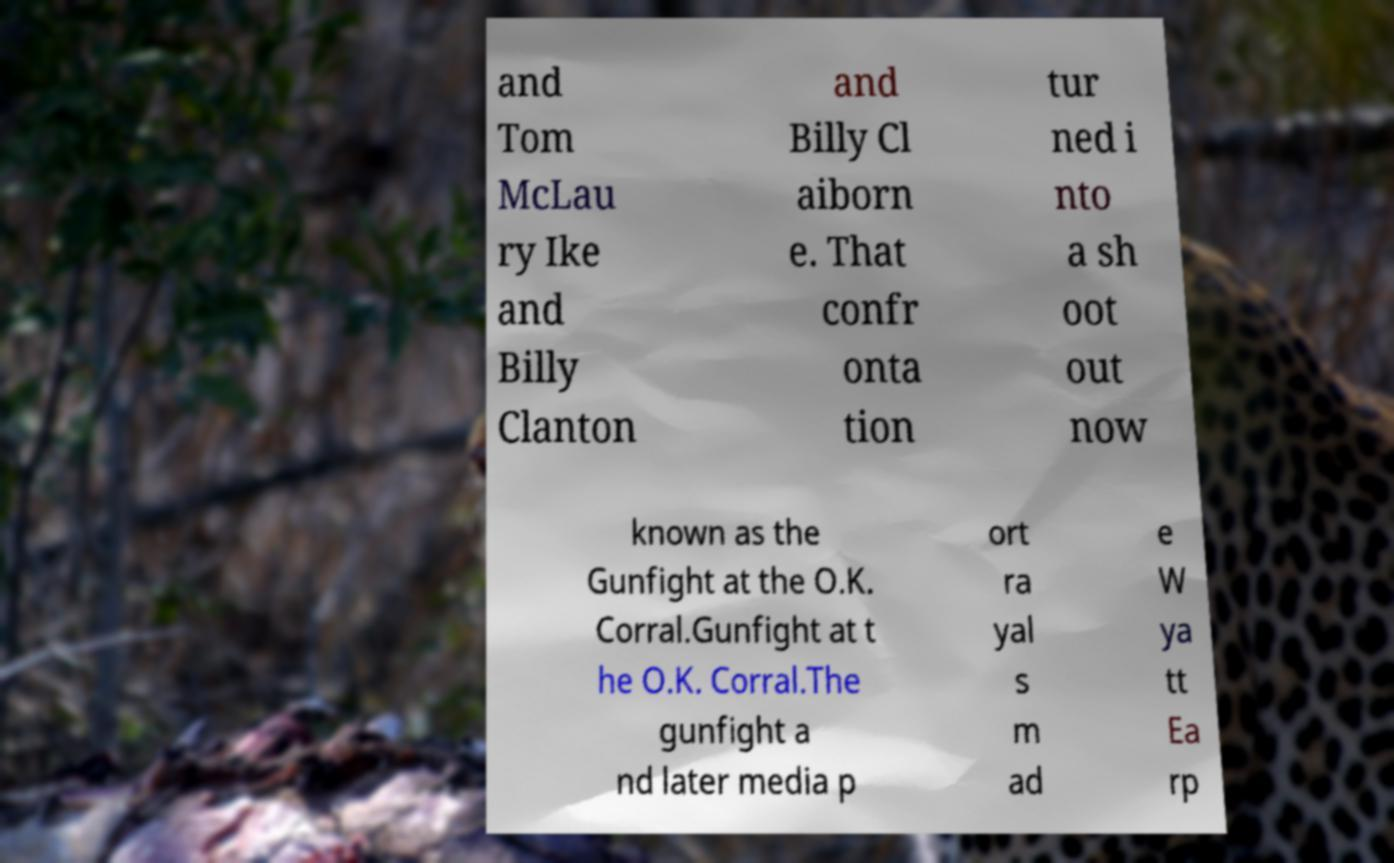For documentation purposes, I need the text within this image transcribed. Could you provide that? and Tom McLau ry Ike and Billy Clanton and Billy Cl aiborn e. That confr onta tion tur ned i nto a sh oot out now known as the Gunfight at the O.K. Corral.Gunfight at t he O.K. Corral.The gunfight a nd later media p ort ra yal s m ad e W ya tt Ea rp 